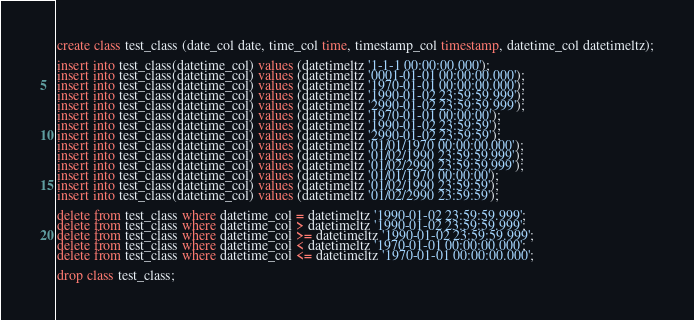<code> <loc_0><loc_0><loc_500><loc_500><_SQL_>create class test_class (date_col date, time_col time, timestamp_col timestamp, datetime_col datetimeltz);

insert into test_class(datetime_col) values (datetimeltz '1-1-1 00:00:00.000');
insert into test_class(datetime_col) values (datetimeltz '0001-01-01 00:00:00.000');
insert into test_class(datetime_col) values (datetimeltz '1970-01-01 00:00:00.000');
insert into test_class(datetime_col) values (datetimeltz '1990-01-02 23:59:59.999');
insert into test_class(datetime_col) values (datetimeltz '2990-01-02 23:59:59.999');
insert into test_class(datetime_col) values (datetimeltz '1970-01-01 00:00:00');
insert into test_class(datetime_col) values (datetimeltz '1990-01-02 23:59:59');
insert into test_class(datetime_col) values (datetimeltz '2990-01-02 23:59:59');
insert into test_class(datetime_col) values (datetimeltz '01/01/1970 00:00:00.000');
insert into test_class(datetime_col) values (datetimeltz '01/02/1990 23:59:59.999');
insert into test_class(datetime_col) values (datetimeltz '01/02/2990 23:59:59.999');
insert into test_class(datetime_col) values (datetimeltz '01/01/1970 00:00:00');
insert into test_class(datetime_col) values (datetimeltz '01/02/1990 23:59:59');
insert into test_class(datetime_col) values (datetimeltz '01/02/2990 23:59:59');

delete from test_class where datetime_col = datetimeltz '1990-01-02 23:59:59.999';
delete from test_class where datetime_col > datetimeltz '1990-01-02 23:59:59.999';
delete from test_class where datetime_col >= datetimeltz '1990-01-02 23:59:59.999';
delete from test_class where datetime_col < datetimeltz '1970-01-01 00:00:00.000';
delete from test_class where datetime_col <= datetimeltz '1970-01-01 00:00:00.000';

drop class test_class;</code> 